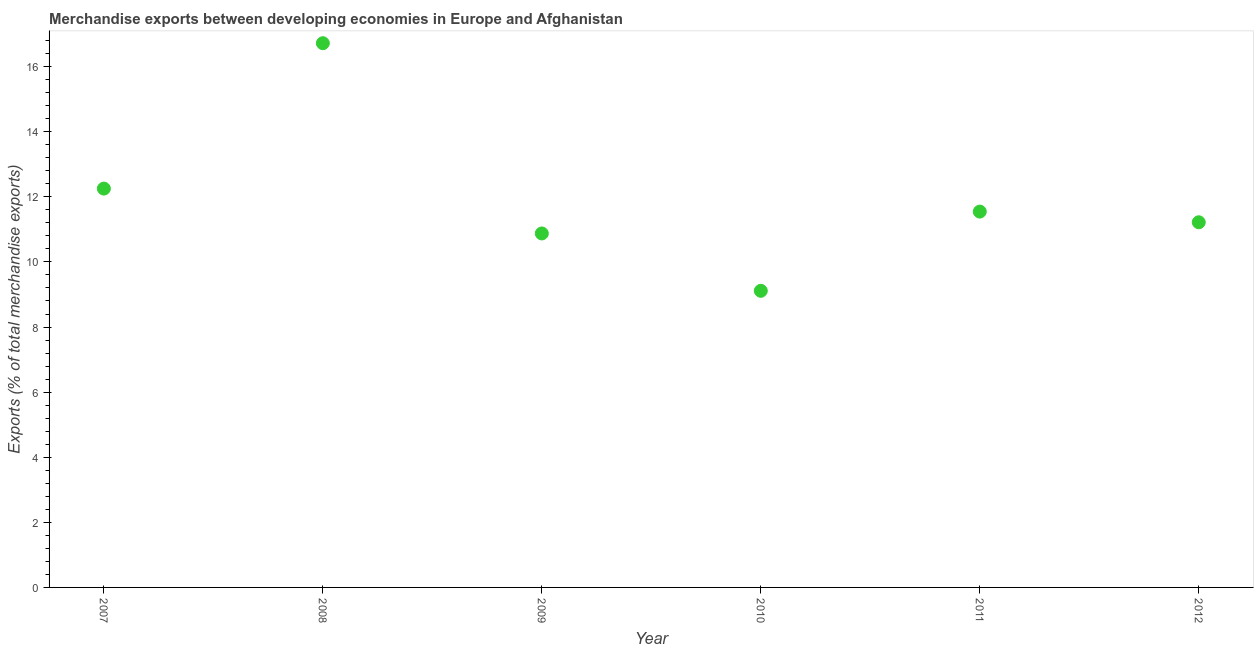What is the merchandise exports in 2009?
Provide a succinct answer. 10.88. Across all years, what is the maximum merchandise exports?
Your answer should be very brief. 16.72. Across all years, what is the minimum merchandise exports?
Your response must be concise. 9.11. In which year was the merchandise exports minimum?
Ensure brevity in your answer.  2010. What is the sum of the merchandise exports?
Your answer should be very brief. 71.72. What is the difference between the merchandise exports in 2010 and 2011?
Ensure brevity in your answer.  -2.43. What is the average merchandise exports per year?
Your answer should be very brief. 11.95. What is the median merchandise exports?
Keep it short and to the point. 11.38. What is the ratio of the merchandise exports in 2007 to that in 2011?
Provide a short and direct response. 1.06. Is the difference between the merchandise exports in 2011 and 2012 greater than the difference between any two years?
Offer a terse response. No. What is the difference between the highest and the second highest merchandise exports?
Offer a terse response. 4.47. Is the sum of the merchandise exports in 2007 and 2011 greater than the maximum merchandise exports across all years?
Keep it short and to the point. Yes. What is the difference between the highest and the lowest merchandise exports?
Your response must be concise. 7.61. In how many years, is the merchandise exports greater than the average merchandise exports taken over all years?
Offer a terse response. 2. Does the merchandise exports monotonically increase over the years?
Offer a very short reply. No. How many dotlines are there?
Offer a terse response. 1. Does the graph contain grids?
Offer a very short reply. No. What is the title of the graph?
Ensure brevity in your answer.  Merchandise exports between developing economies in Europe and Afghanistan. What is the label or title of the X-axis?
Provide a short and direct response. Year. What is the label or title of the Y-axis?
Give a very brief answer. Exports (% of total merchandise exports). What is the Exports (% of total merchandise exports) in 2007?
Provide a short and direct response. 12.25. What is the Exports (% of total merchandise exports) in 2008?
Offer a very short reply. 16.72. What is the Exports (% of total merchandise exports) in 2009?
Your answer should be compact. 10.88. What is the Exports (% of total merchandise exports) in 2010?
Provide a short and direct response. 9.11. What is the Exports (% of total merchandise exports) in 2011?
Your answer should be compact. 11.55. What is the Exports (% of total merchandise exports) in 2012?
Give a very brief answer. 11.22. What is the difference between the Exports (% of total merchandise exports) in 2007 and 2008?
Your answer should be compact. -4.47. What is the difference between the Exports (% of total merchandise exports) in 2007 and 2009?
Keep it short and to the point. 1.38. What is the difference between the Exports (% of total merchandise exports) in 2007 and 2010?
Offer a very short reply. 3.14. What is the difference between the Exports (% of total merchandise exports) in 2007 and 2011?
Provide a short and direct response. 0.71. What is the difference between the Exports (% of total merchandise exports) in 2007 and 2012?
Provide a short and direct response. 1.03. What is the difference between the Exports (% of total merchandise exports) in 2008 and 2009?
Provide a succinct answer. 5.84. What is the difference between the Exports (% of total merchandise exports) in 2008 and 2010?
Ensure brevity in your answer.  7.61. What is the difference between the Exports (% of total merchandise exports) in 2008 and 2011?
Make the answer very short. 5.17. What is the difference between the Exports (% of total merchandise exports) in 2008 and 2012?
Provide a succinct answer. 5.5. What is the difference between the Exports (% of total merchandise exports) in 2009 and 2010?
Keep it short and to the point. 1.76. What is the difference between the Exports (% of total merchandise exports) in 2009 and 2011?
Your response must be concise. -0.67. What is the difference between the Exports (% of total merchandise exports) in 2009 and 2012?
Offer a terse response. -0.34. What is the difference between the Exports (% of total merchandise exports) in 2010 and 2011?
Your response must be concise. -2.43. What is the difference between the Exports (% of total merchandise exports) in 2010 and 2012?
Provide a short and direct response. -2.11. What is the difference between the Exports (% of total merchandise exports) in 2011 and 2012?
Your answer should be very brief. 0.33. What is the ratio of the Exports (% of total merchandise exports) in 2007 to that in 2008?
Offer a terse response. 0.73. What is the ratio of the Exports (% of total merchandise exports) in 2007 to that in 2009?
Offer a very short reply. 1.13. What is the ratio of the Exports (% of total merchandise exports) in 2007 to that in 2010?
Give a very brief answer. 1.34. What is the ratio of the Exports (% of total merchandise exports) in 2007 to that in 2011?
Your answer should be very brief. 1.06. What is the ratio of the Exports (% of total merchandise exports) in 2007 to that in 2012?
Provide a short and direct response. 1.09. What is the ratio of the Exports (% of total merchandise exports) in 2008 to that in 2009?
Offer a very short reply. 1.54. What is the ratio of the Exports (% of total merchandise exports) in 2008 to that in 2010?
Your answer should be very brief. 1.83. What is the ratio of the Exports (% of total merchandise exports) in 2008 to that in 2011?
Your response must be concise. 1.45. What is the ratio of the Exports (% of total merchandise exports) in 2008 to that in 2012?
Your response must be concise. 1.49. What is the ratio of the Exports (% of total merchandise exports) in 2009 to that in 2010?
Your answer should be compact. 1.19. What is the ratio of the Exports (% of total merchandise exports) in 2009 to that in 2011?
Offer a terse response. 0.94. What is the ratio of the Exports (% of total merchandise exports) in 2009 to that in 2012?
Give a very brief answer. 0.97. What is the ratio of the Exports (% of total merchandise exports) in 2010 to that in 2011?
Ensure brevity in your answer.  0.79. What is the ratio of the Exports (% of total merchandise exports) in 2010 to that in 2012?
Your answer should be very brief. 0.81. 